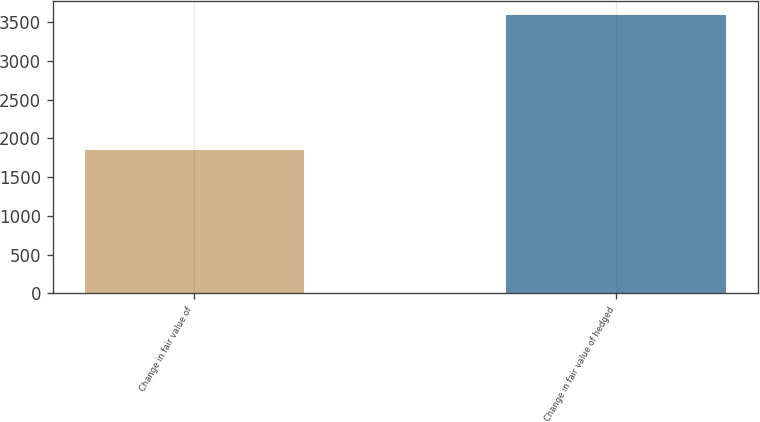Convert chart. <chart><loc_0><loc_0><loc_500><loc_500><bar_chart><fcel>Change in fair value of<fcel>Change in fair value of hedged<nl><fcel>1847<fcel>3594.2<nl></chart> 